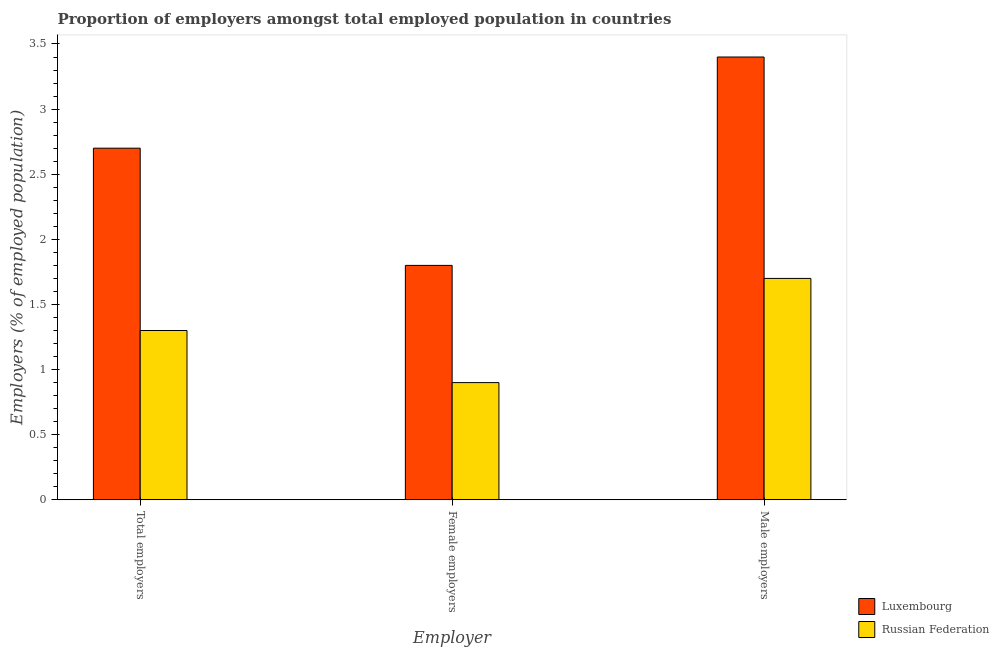How many different coloured bars are there?
Keep it short and to the point. 2. How many bars are there on the 2nd tick from the right?
Offer a very short reply. 2. What is the label of the 2nd group of bars from the left?
Keep it short and to the point. Female employers. What is the percentage of female employers in Russian Federation?
Your response must be concise. 0.9. Across all countries, what is the maximum percentage of female employers?
Your response must be concise. 1.8. Across all countries, what is the minimum percentage of male employers?
Ensure brevity in your answer.  1.7. In which country was the percentage of female employers maximum?
Your answer should be compact. Luxembourg. In which country was the percentage of female employers minimum?
Provide a succinct answer. Russian Federation. What is the total percentage of total employers in the graph?
Your answer should be very brief. 4. What is the difference between the percentage of female employers in Russian Federation and that in Luxembourg?
Ensure brevity in your answer.  -0.9. What is the difference between the percentage of female employers in Russian Federation and the percentage of total employers in Luxembourg?
Offer a terse response. -1.8. What is the average percentage of total employers per country?
Keep it short and to the point. 2. What is the difference between the percentage of male employers and percentage of total employers in Luxembourg?
Provide a short and direct response. 0.7. In how many countries, is the percentage of total employers greater than 2.3 %?
Ensure brevity in your answer.  1. What is the ratio of the percentage of female employers in Luxembourg to that in Russian Federation?
Your answer should be compact. 2. Is the difference between the percentage of female employers in Russian Federation and Luxembourg greater than the difference between the percentage of total employers in Russian Federation and Luxembourg?
Your response must be concise. Yes. What is the difference between the highest and the second highest percentage of male employers?
Offer a very short reply. 1.7. What is the difference between the highest and the lowest percentage of female employers?
Give a very brief answer. 0.9. Is the sum of the percentage of female employers in Russian Federation and Luxembourg greater than the maximum percentage of total employers across all countries?
Provide a succinct answer. No. What does the 1st bar from the left in Total employers represents?
Your response must be concise. Luxembourg. What does the 2nd bar from the right in Male employers represents?
Your response must be concise. Luxembourg. Is it the case that in every country, the sum of the percentage of total employers and percentage of female employers is greater than the percentage of male employers?
Give a very brief answer. Yes. Are all the bars in the graph horizontal?
Give a very brief answer. No. Are the values on the major ticks of Y-axis written in scientific E-notation?
Make the answer very short. No. Does the graph contain any zero values?
Offer a very short reply. No. Where does the legend appear in the graph?
Keep it short and to the point. Bottom right. How many legend labels are there?
Your response must be concise. 2. How are the legend labels stacked?
Offer a very short reply. Vertical. What is the title of the graph?
Your response must be concise. Proportion of employers amongst total employed population in countries. Does "Azerbaijan" appear as one of the legend labels in the graph?
Your answer should be compact. No. What is the label or title of the X-axis?
Keep it short and to the point. Employer. What is the label or title of the Y-axis?
Your response must be concise. Employers (% of employed population). What is the Employers (% of employed population) in Luxembourg in Total employers?
Your answer should be compact. 2.7. What is the Employers (% of employed population) in Russian Federation in Total employers?
Your answer should be compact. 1.3. What is the Employers (% of employed population) in Luxembourg in Female employers?
Offer a terse response. 1.8. What is the Employers (% of employed population) of Russian Federation in Female employers?
Give a very brief answer. 0.9. What is the Employers (% of employed population) in Luxembourg in Male employers?
Your response must be concise. 3.4. What is the Employers (% of employed population) of Russian Federation in Male employers?
Provide a short and direct response. 1.7. Across all Employer, what is the maximum Employers (% of employed population) of Luxembourg?
Your answer should be compact. 3.4. Across all Employer, what is the maximum Employers (% of employed population) of Russian Federation?
Keep it short and to the point. 1.7. Across all Employer, what is the minimum Employers (% of employed population) in Luxembourg?
Provide a succinct answer. 1.8. Across all Employer, what is the minimum Employers (% of employed population) in Russian Federation?
Your answer should be compact. 0.9. What is the total Employers (% of employed population) in Luxembourg in the graph?
Offer a very short reply. 7.9. What is the total Employers (% of employed population) in Russian Federation in the graph?
Your answer should be compact. 3.9. What is the difference between the Employers (% of employed population) of Luxembourg in Total employers and that in Female employers?
Keep it short and to the point. 0.9. What is the difference between the Employers (% of employed population) of Luxembourg in Total employers and that in Male employers?
Your answer should be very brief. -0.7. What is the difference between the Employers (% of employed population) of Luxembourg in Female employers and that in Male employers?
Your answer should be compact. -1.6. What is the difference between the Employers (% of employed population) of Russian Federation in Female employers and that in Male employers?
Provide a succinct answer. -0.8. What is the difference between the Employers (% of employed population) in Luxembourg in Female employers and the Employers (% of employed population) in Russian Federation in Male employers?
Your answer should be compact. 0.1. What is the average Employers (% of employed population) of Luxembourg per Employer?
Provide a short and direct response. 2.63. What is the difference between the Employers (% of employed population) in Luxembourg and Employers (% of employed population) in Russian Federation in Total employers?
Your answer should be compact. 1.4. What is the difference between the Employers (% of employed population) of Luxembourg and Employers (% of employed population) of Russian Federation in Female employers?
Your response must be concise. 0.9. What is the ratio of the Employers (% of employed population) of Luxembourg in Total employers to that in Female employers?
Your answer should be compact. 1.5. What is the ratio of the Employers (% of employed population) of Russian Federation in Total employers to that in Female employers?
Make the answer very short. 1.44. What is the ratio of the Employers (% of employed population) in Luxembourg in Total employers to that in Male employers?
Your response must be concise. 0.79. What is the ratio of the Employers (% of employed population) in Russian Federation in Total employers to that in Male employers?
Your response must be concise. 0.76. What is the ratio of the Employers (% of employed population) in Luxembourg in Female employers to that in Male employers?
Keep it short and to the point. 0.53. What is the ratio of the Employers (% of employed population) in Russian Federation in Female employers to that in Male employers?
Offer a terse response. 0.53. What is the difference between the highest and the second highest Employers (% of employed population) of Luxembourg?
Ensure brevity in your answer.  0.7. What is the difference between the highest and the lowest Employers (% of employed population) of Russian Federation?
Make the answer very short. 0.8. 